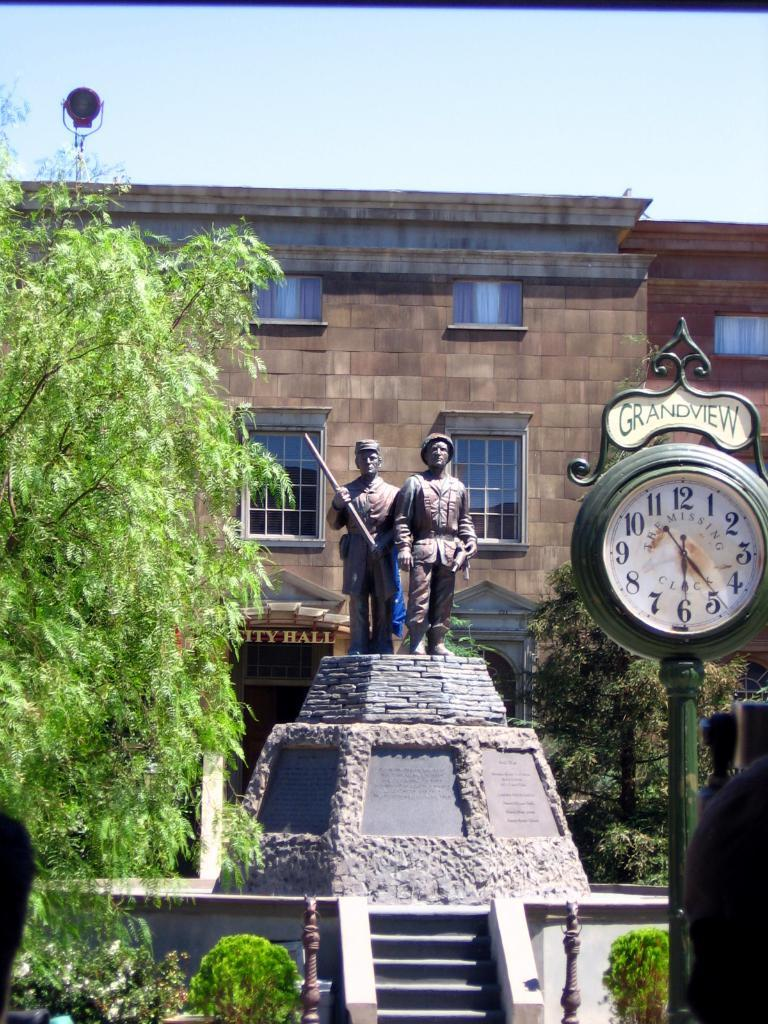<image>
Describe the image concisely. A statue with two men behind a clock that says grandview. 